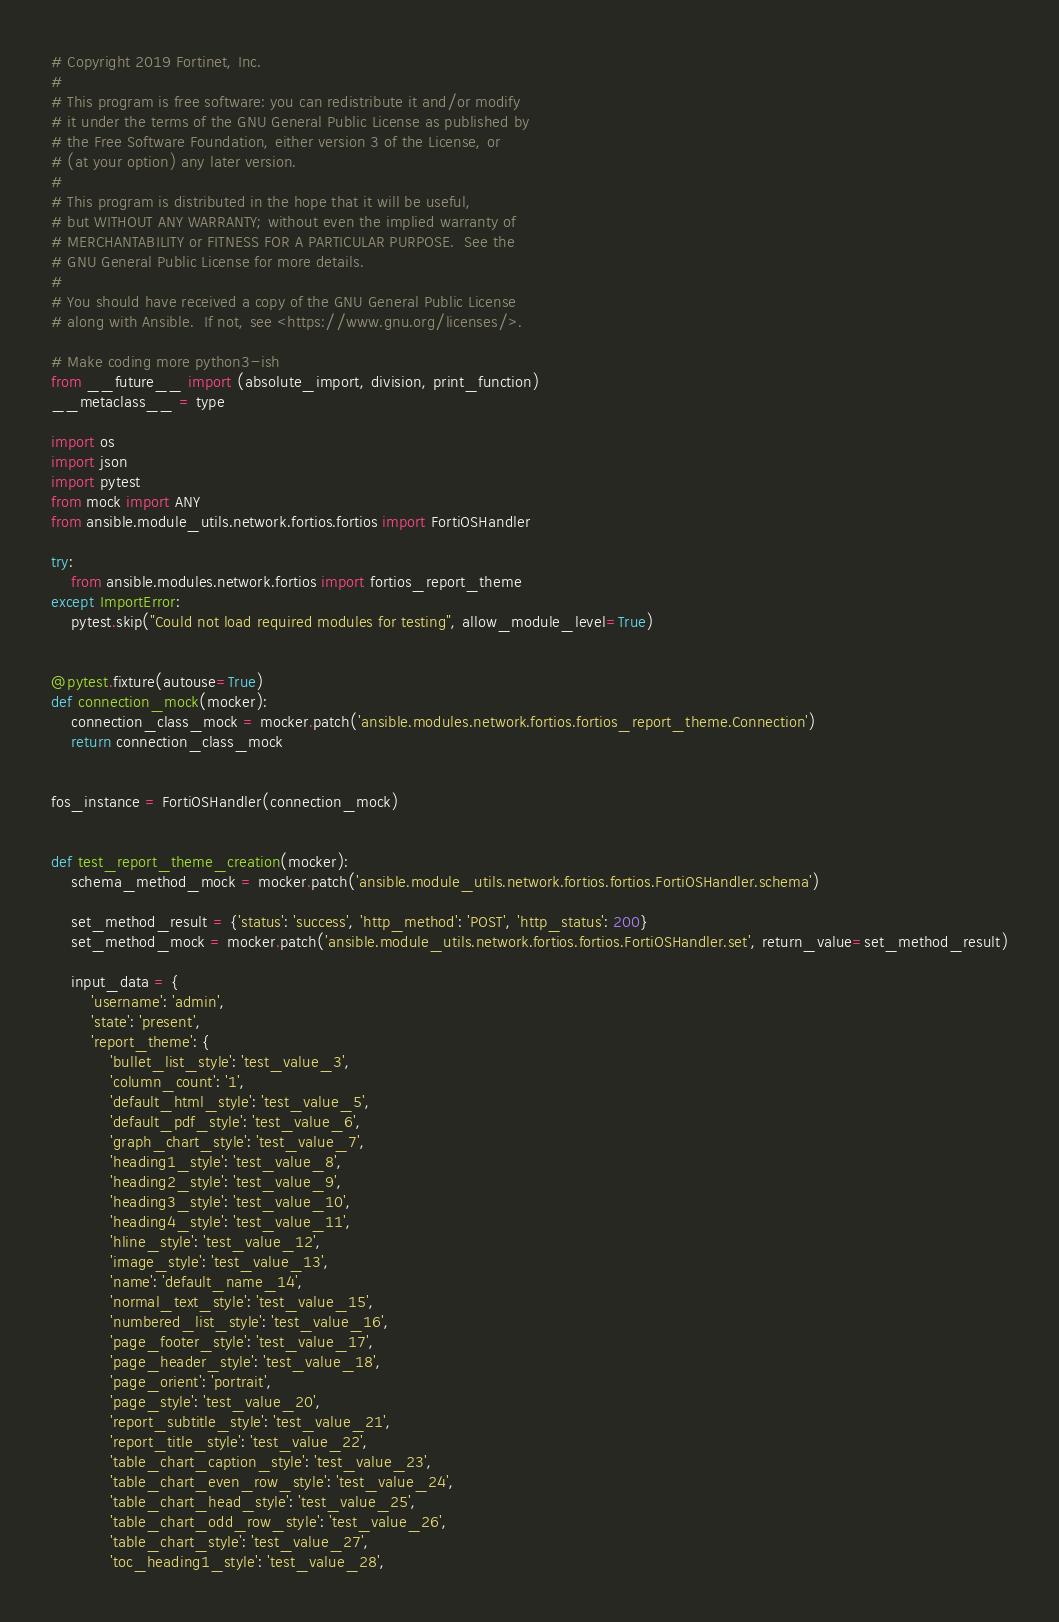Convert code to text. <code><loc_0><loc_0><loc_500><loc_500><_Python_># Copyright 2019 Fortinet, Inc.
#
# This program is free software: you can redistribute it and/or modify
# it under the terms of the GNU General Public License as published by
# the Free Software Foundation, either version 3 of the License, or
# (at your option) any later version.
#
# This program is distributed in the hope that it will be useful,
# but WITHOUT ANY WARRANTY; without even the implied warranty of
# MERCHANTABILITY or FITNESS FOR A PARTICULAR PURPOSE.  See the
# GNU General Public License for more details.
#
# You should have received a copy of the GNU General Public License
# along with Ansible.  If not, see <https://www.gnu.org/licenses/>.

# Make coding more python3-ish
from __future__ import (absolute_import, division, print_function)
__metaclass__ = type

import os
import json
import pytest
from mock import ANY
from ansible.module_utils.network.fortios.fortios import FortiOSHandler

try:
    from ansible.modules.network.fortios import fortios_report_theme
except ImportError:
    pytest.skip("Could not load required modules for testing", allow_module_level=True)


@pytest.fixture(autouse=True)
def connection_mock(mocker):
    connection_class_mock = mocker.patch('ansible.modules.network.fortios.fortios_report_theme.Connection')
    return connection_class_mock


fos_instance = FortiOSHandler(connection_mock)


def test_report_theme_creation(mocker):
    schema_method_mock = mocker.patch('ansible.module_utils.network.fortios.fortios.FortiOSHandler.schema')

    set_method_result = {'status': 'success', 'http_method': 'POST', 'http_status': 200}
    set_method_mock = mocker.patch('ansible.module_utils.network.fortios.fortios.FortiOSHandler.set', return_value=set_method_result)

    input_data = {
        'username': 'admin',
        'state': 'present',
        'report_theme': {
            'bullet_list_style': 'test_value_3',
            'column_count': '1',
            'default_html_style': 'test_value_5',
            'default_pdf_style': 'test_value_6',
            'graph_chart_style': 'test_value_7',
            'heading1_style': 'test_value_8',
            'heading2_style': 'test_value_9',
            'heading3_style': 'test_value_10',
            'heading4_style': 'test_value_11',
            'hline_style': 'test_value_12',
            'image_style': 'test_value_13',
            'name': 'default_name_14',
            'normal_text_style': 'test_value_15',
            'numbered_list_style': 'test_value_16',
            'page_footer_style': 'test_value_17',
            'page_header_style': 'test_value_18',
            'page_orient': 'portrait',
            'page_style': 'test_value_20',
            'report_subtitle_style': 'test_value_21',
            'report_title_style': 'test_value_22',
            'table_chart_caption_style': 'test_value_23',
            'table_chart_even_row_style': 'test_value_24',
            'table_chart_head_style': 'test_value_25',
            'table_chart_odd_row_style': 'test_value_26',
            'table_chart_style': 'test_value_27',
            'toc_heading1_style': 'test_value_28',</code> 